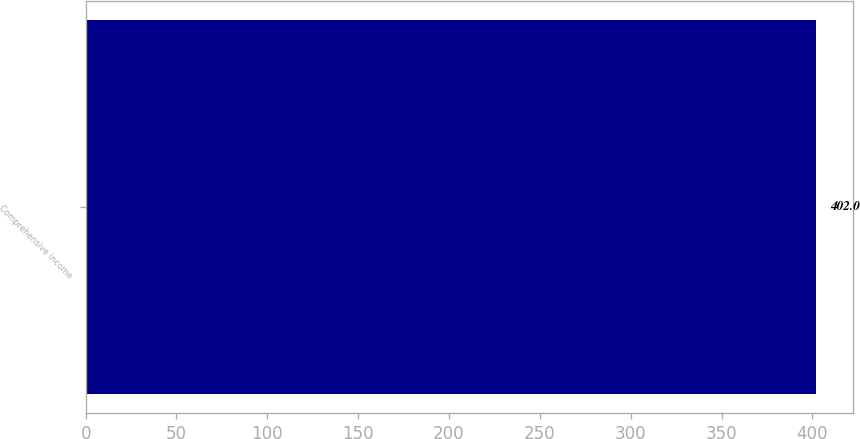Convert chart. <chart><loc_0><loc_0><loc_500><loc_500><bar_chart><fcel>Comprehensive income<nl><fcel>402<nl></chart> 